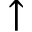Convert formula to latex. <formula><loc_0><loc_0><loc_500><loc_500>\uparrow</formula> 